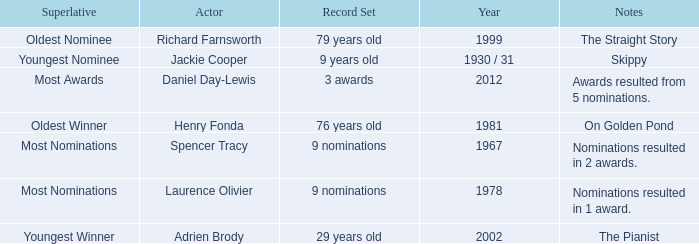What actor won in 1978? Laurence Olivier. 